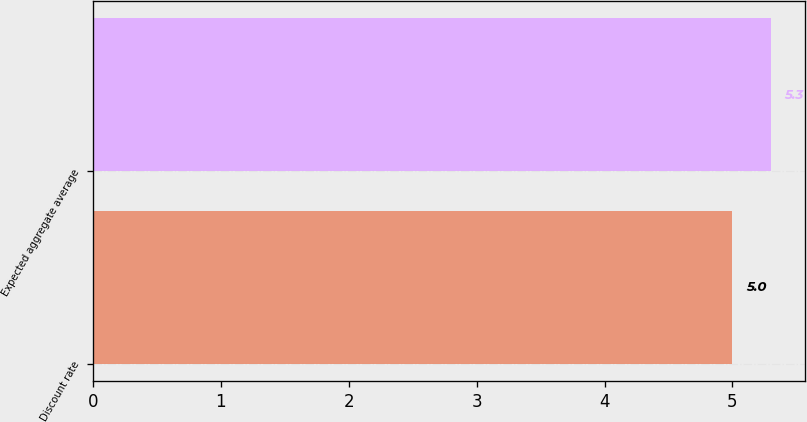Convert chart. <chart><loc_0><loc_0><loc_500><loc_500><bar_chart><fcel>Discount rate<fcel>Expected aggregate average<nl><fcel>5<fcel>5.3<nl></chart> 